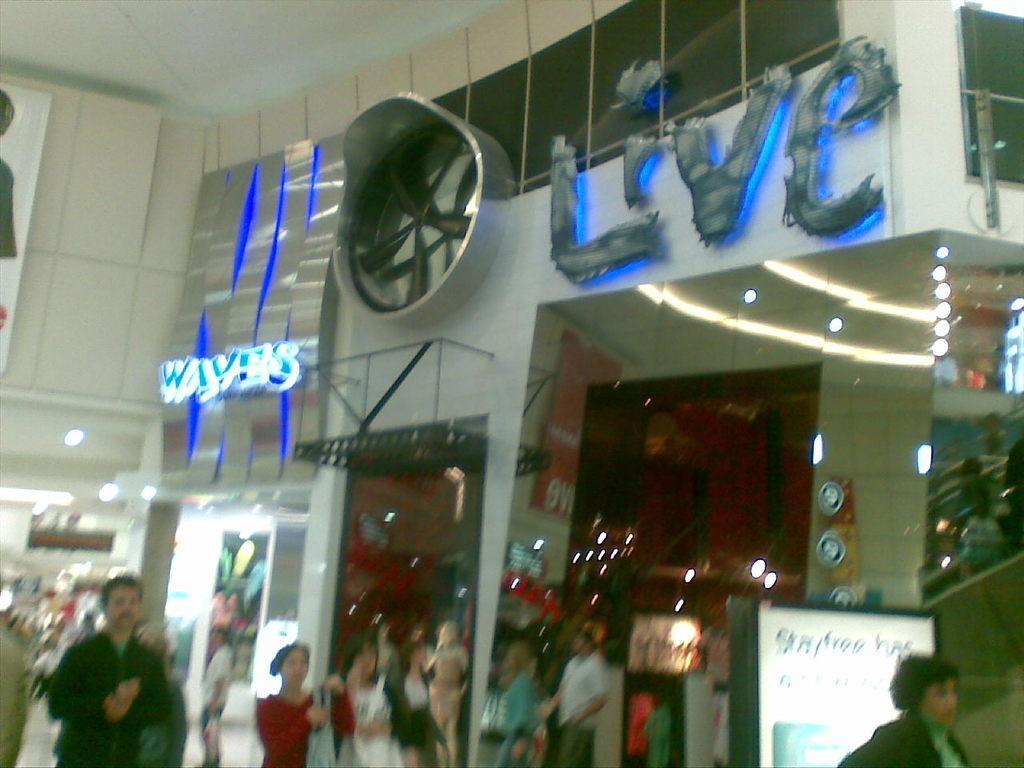How would you summarize this image in a sentence or two? The image is taken inside the building. At the bottom of the image we can see people walking. There are boards and we can see stores. 